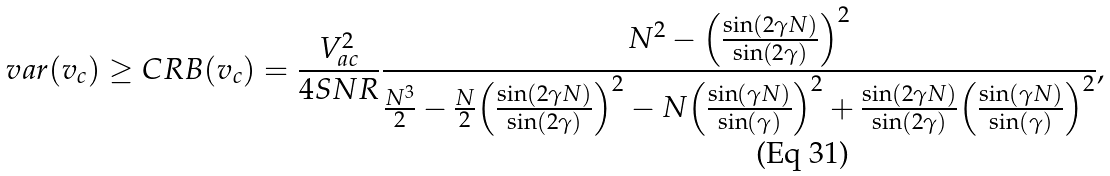<formula> <loc_0><loc_0><loc_500><loc_500>v a r ( v _ { c } ) \geq C R B ( v _ { c } ) = \frac { V _ { a c } ^ { 2 } } { 4 S N R } \frac { N ^ { 2 } - { \left ( \frac { \sin ( 2 \gamma N ) } { \sin ( 2 \gamma ) } \right ) } ^ { 2 } } { \frac { N ^ { 3 } } { 2 } - \frac { N } { 2 } { \left ( \frac { \sin ( 2 \gamma N ) } { \sin ( 2 \gamma ) } \right ) } ^ { 2 } - N { \left ( \frac { \sin ( \gamma N ) } { \sin ( \gamma ) } \right ) } ^ { 2 } + \frac { \sin ( 2 \gamma N ) } { \sin ( 2 \gamma ) } { \left ( \frac { \sin ( \gamma N ) } { \sin ( \gamma ) } \right ) } ^ { 2 } } ,</formula> 